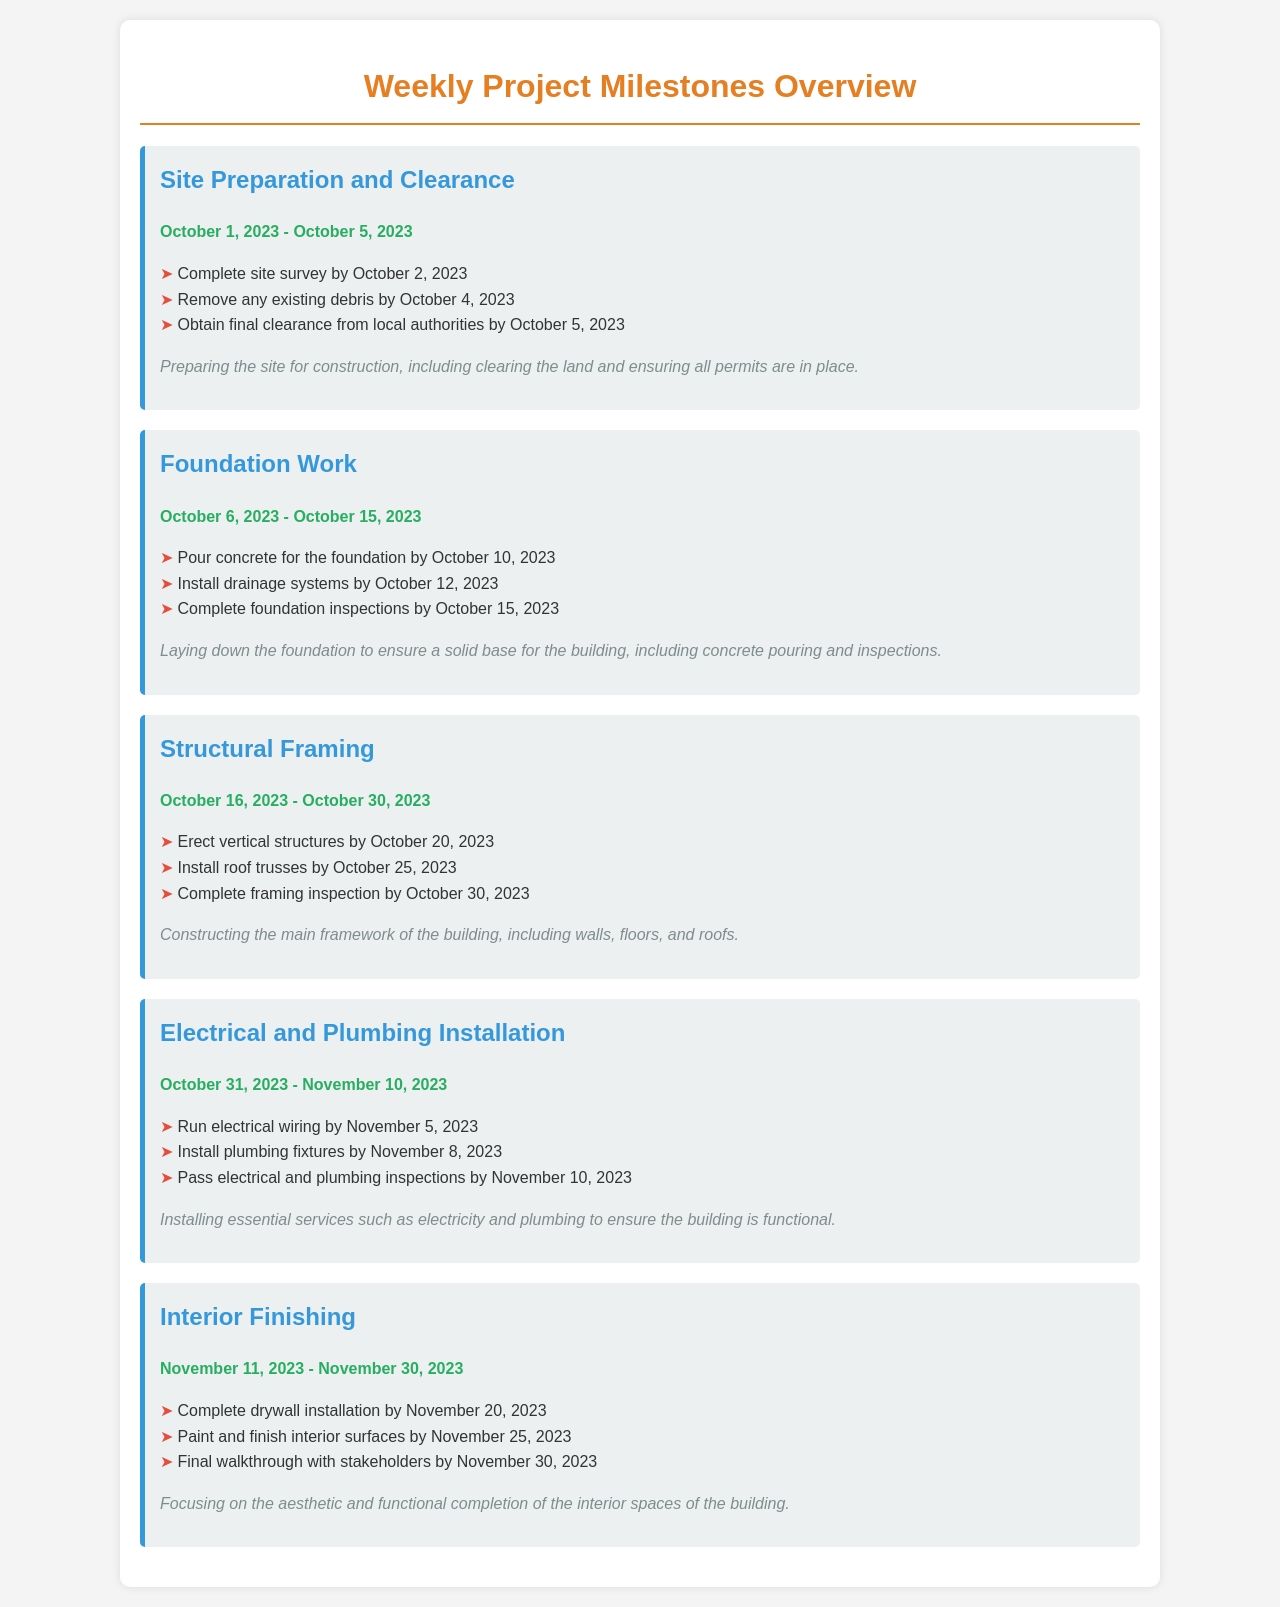What is the first milestone? The first milestone listed in the document is "Site Preparation and Clearance."
Answer: Site Preparation and Clearance When does the Foundation Work start? The start date of the Foundation Work milestone is specifically stated in the document.
Answer: October 6, 2023 What task needs to be completed by October 10, 2023? The document lists specific tasks with deadlines; one task is pouring concrete for the foundation.
Answer: Pour concrete for the foundation What is the final deadline for Electrical and Plumbing Installation? The document includes a specific end date for the Electrical and Plumbing Installation milestone.
Answer: November 10, 2023 How many days are allocated for Interior Finishing? The document specifies the start and end dates for the Interior Finishing milestone.
Answer: 20 days What is the last task to complete for the Structural Framing? The document details tasks for each milestone, including the last one for the Structural Framing.
Answer: Complete framing inspection When is the paint and finish of interior surfaces scheduled to be done? The document lists specific tasks with deadlines; one task is to paint and finish interior surfaces.
Answer: November 25, 2023 What is the purpose of the "Site Preparation and Clearance" milestone? The document provides a brief description of what each milestone entails, including this one.
Answer: Preparing the site for construction What inspection is due by October 15, 2023? The document indicates specific inspections required for milestones, particularly for the Foundation Work.
Answer: Complete foundation inspections 